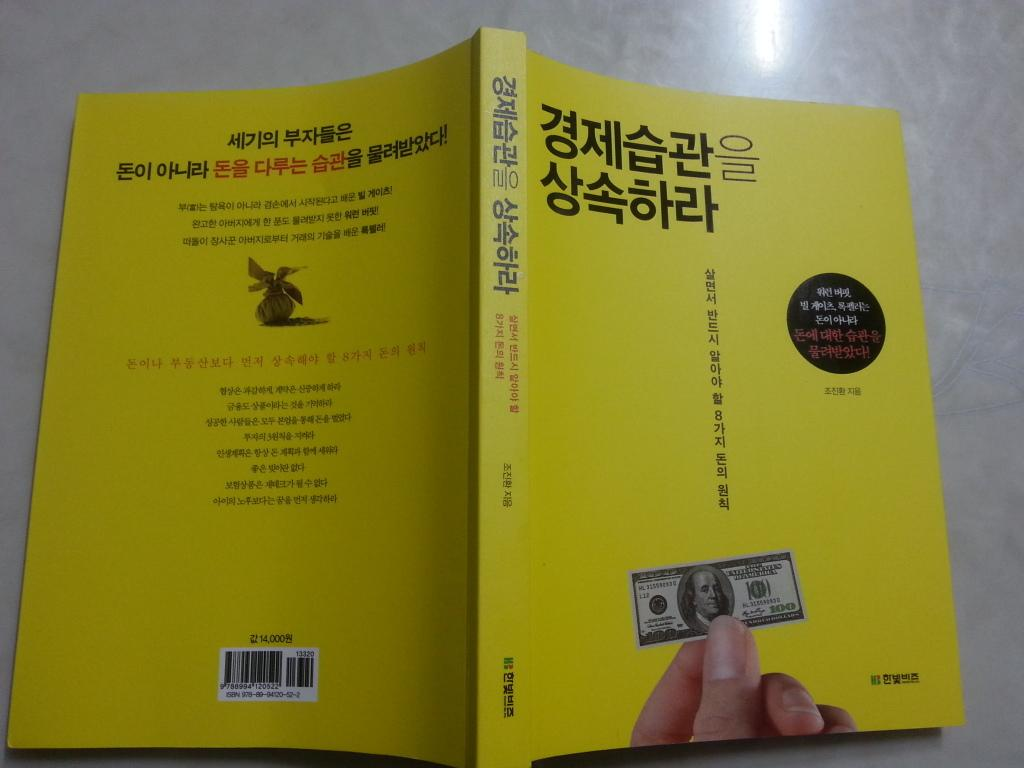<image>
Share a concise interpretation of the image provided. A yellow book in some south Asian text and a United States of America 100 dollar bill on the cover. 